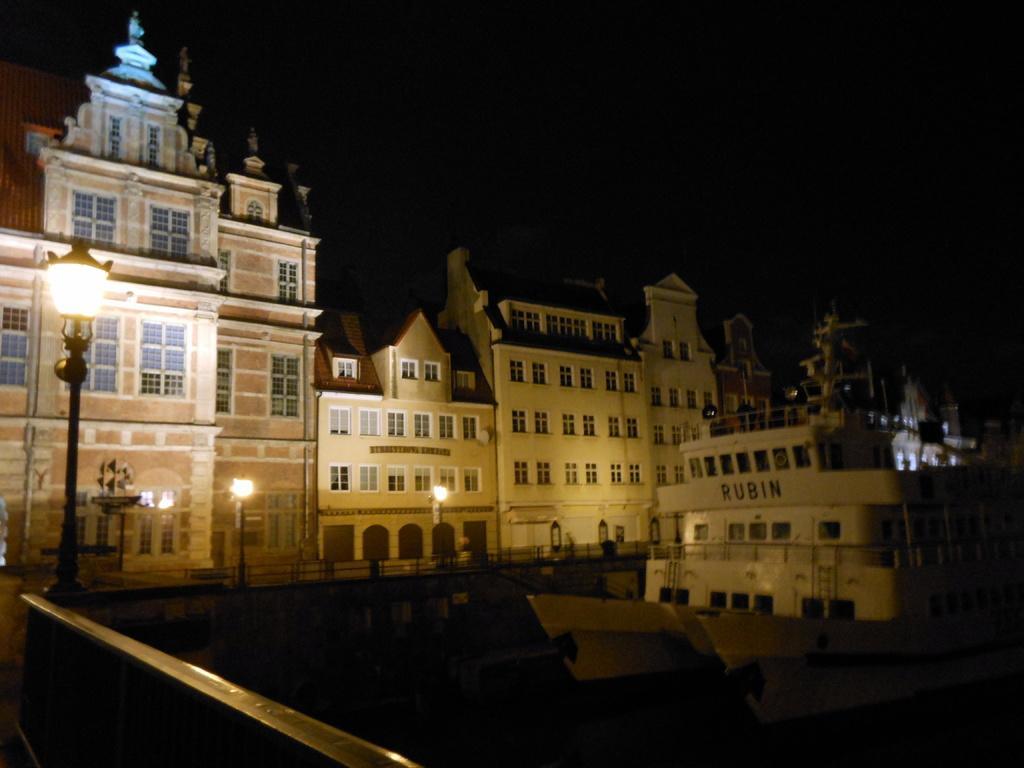Please provide a concise description of this image. In this image I can see at the bottom there is water, on the right side it looks like a ship. In the middle there is a very big building and there are lamps. At the top it is the sky in the dark knight. 